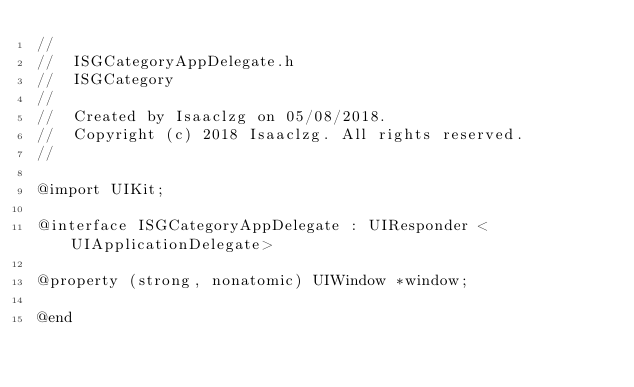Convert code to text. <code><loc_0><loc_0><loc_500><loc_500><_C_>//
//  ISGCategoryAppDelegate.h
//  ISGCategory
//
//  Created by Isaaclzg on 05/08/2018.
//  Copyright (c) 2018 Isaaclzg. All rights reserved.
//

@import UIKit;

@interface ISGCategoryAppDelegate : UIResponder <UIApplicationDelegate>

@property (strong, nonatomic) UIWindow *window;

@end
</code> 